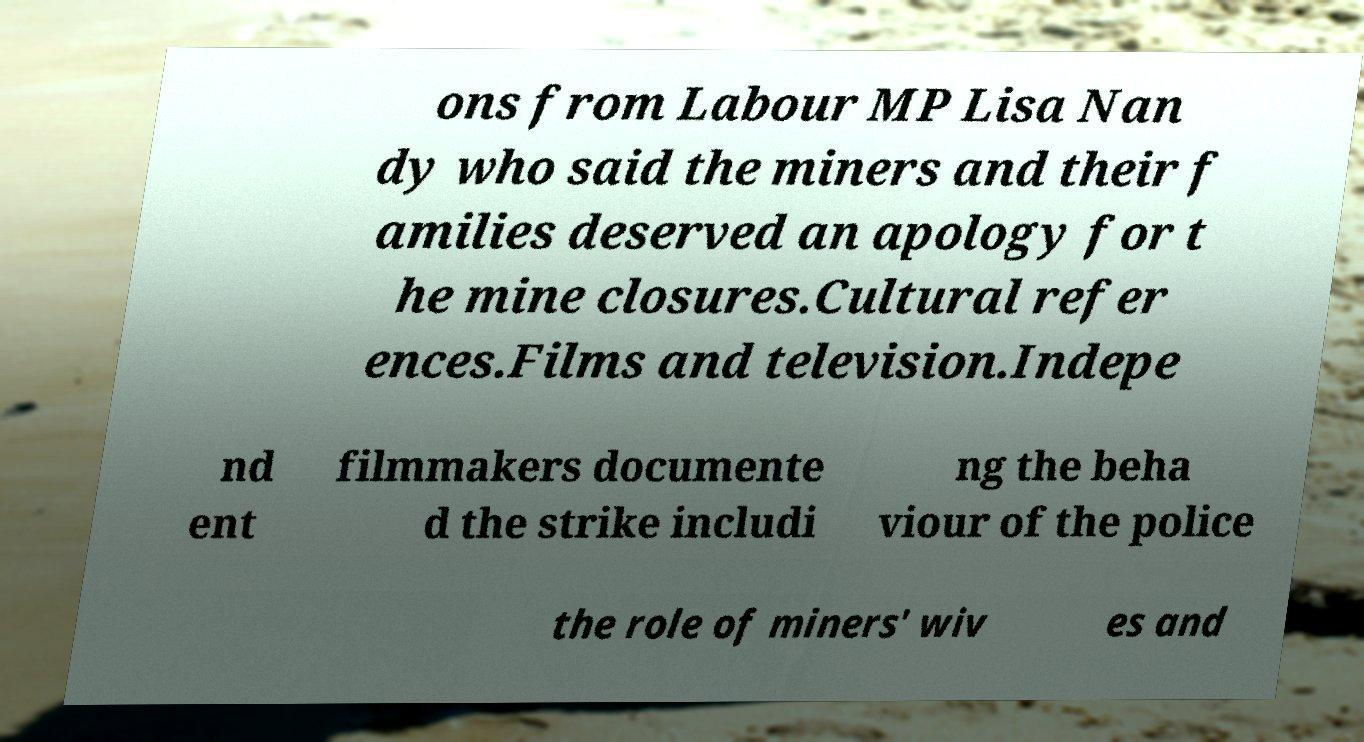Could you assist in decoding the text presented in this image and type it out clearly? ons from Labour MP Lisa Nan dy who said the miners and their f amilies deserved an apology for t he mine closures.Cultural refer ences.Films and television.Indepe nd ent filmmakers documente d the strike includi ng the beha viour of the police the role of miners' wiv es and 